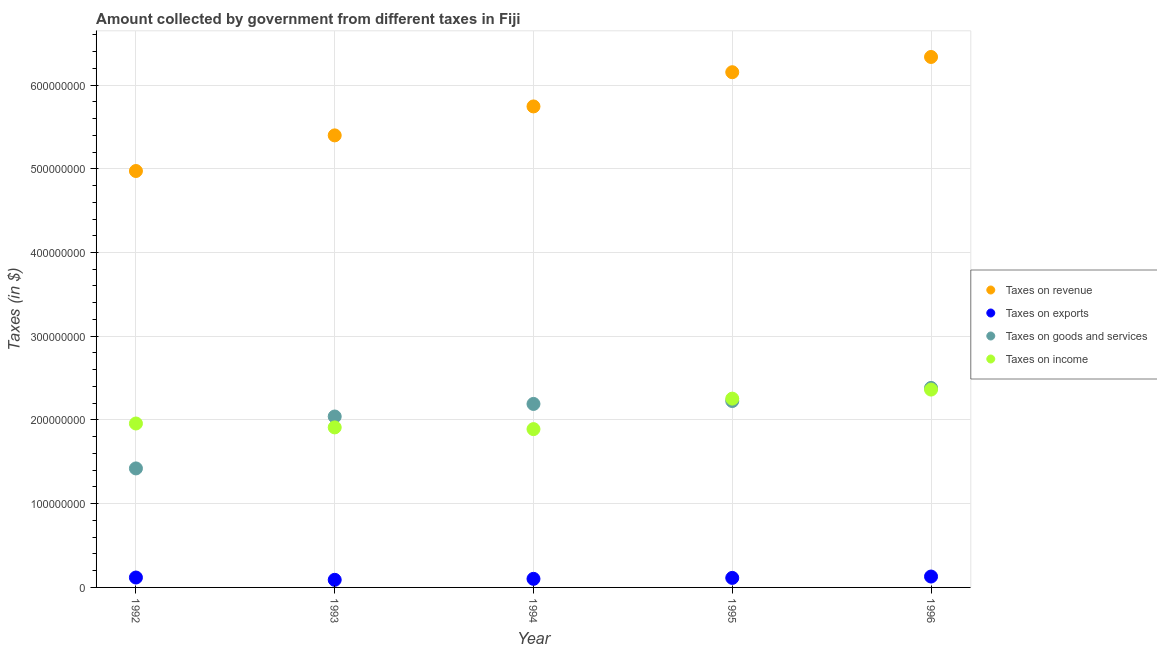How many different coloured dotlines are there?
Ensure brevity in your answer.  4. Is the number of dotlines equal to the number of legend labels?
Offer a very short reply. Yes. What is the amount collected as tax on revenue in 1996?
Your answer should be very brief. 6.34e+08. Across all years, what is the maximum amount collected as tax on income?
Offer a terse response. 2.36e+08. Across all years, what is the minimum amount collected as tax on exports?
Your answer should be very brief. 9.08e+06. In which year was the amount collected as tax on revenue maximum?
Provide a succinct answer. 1996. In which year was the amount collected as tax on exports minimum?
Offer a terse response. 1993. What is the total amount collected as tax on revenue in the graph?
Make the answer very short. 2.86e+09. What is the difference between the amount collected as tax on exports in 1993 and that in 1996?
Your response must be concise. -3.93e+06. What is the difference between the amount collected as tax on exports in 1994 and the amount collected as tax on revenue in 1992?
Your answer should be compact. -4.87e+08. What is the average amount collected as tax on goods per year?
Give a very brief answer. 2.05e+08. In the year 1994, what is the difference between the amount collected as tax on goods and amount collected as tax on income?
Your response must be concise. 3.01e+07. In how many years, is the amount collected as tax on exports greater than 220000000 $?
Your answer should be very brief. 0. What is the ratio of the amount collected as tax on goods in 1992 to that in 1995?
Provide a succinct answer. 0.64. What is the difference between the highest and the second highest amount collected as tax on exports?
Ensure brevity in your answer.  1.18e+06. What is the difference between the highest and the lowest amount collected as tax on revenue?
Keep it short and to the point. 1.36e+08. In how many years, is the amount collected as tax on income greater than the average amount collected as tax on income taken over all years?
Provide a succinct answer. 2. Is the sum of the amount collected as tax on income in 1994 and 1996 greater than the maximum amount collected as tax on revenue across all years?
Ensure brevity in your answer.  No. Is it the case that in every year, the sum of the amount collected as tax on income and amount collected as tax on exports is greater than the sum of amount collected as tax on goods and amount collected as tax on revenue?
Your answer should be very brief. No. Is it the case that in every year, the sum of the amount collected as tax on revenue and amount collected as tax on exports is greater than the amount collected as tax on goods?
Provide a succinct answer. Yes. Does the amount collected as tax on exports monotonically increase over the years?
Provide a succinct answer. No. Is the amount collected as tax on exports strictly greater than the amount collected as tax on income over the years?
Provide a succinct answer. No. What is the difference between two consecutive major ticks on the Y-axis?
Keep it short and to the point. 1.00e+08. Are the values on the major ticks of Y-axis written in scientific E-notation?
Give a very brief answer. No. Does the graph contain any zero values?
Keep it short and to the point. No. Where does the legend appear in the graph?
Make the answer very short. Center right. How are the legend labels stacked?
Give a very brief answer. Vertical. What is the title of the graph?
Your answer should be compact. Amount collected by government from different taxes in Fiji. Does "Self-employed" appear as one of the legend labels in the graph?
Give a very brief answer. No. What is the label or title of the X-axis?
Your answer should be compact. Year. What is the label or title of the Y-axis?
Ensure brevity in your answer.  Taxes (in $). What is the Taxes (in $) in Taxes on revenue in 1992?
Provide a short and direct response. 4.97e+08. What is the Taxes (in $) in Taxes on exports in 1992?
Make the answer very short. 1.18e+07. What is the Taxes (in $) in Taxes on goods and services in 1992?
Keep it short and to the point. 1.42e+08. What is the Taxes (in $) in Taxes on income in 1992?
Offer a very short reply. 1.96e+08. What is the Taxes (in $) in Taxes on revenue in 1993?
Your answer should be compact. 5.40e+08. What is the Taxes (in $) in Taxes on exports in 1993?
Keep it short and to the point. 9.08e+06. What is the Taxes (in $) of Taxes on goods and services in 1993?
Provide a succinct answer. 2.04e+08. What is the Taxes (in $) of Taxes on income in 1993?
Your response must be concise. 1.91e+08. What is the Taxes (in $) of Taxes on revenue in 1994?
Keep it short and to the point. 5.74e+08. What is the Taxes (in $) in Taxes on exports in 1994?
Your answer should be compact. 1.02e+07. What is the Taxes (in $) of Taxes on goods and services in 1994?
Offer a very short reply. 2.19e+08. What is the Taxes (in $) in Taxes on income in 1994?
Your answer should be very brief. 1.89e+08. What is the Taxes (in $) of Taxes on revenue in 1995?
Offer a very short reply. 6.15e+08. What is the Taxes (in $) in Taxes on exports in 1995?
Keep it short and to the point. 1.14e+07. What is the Taxes (in $) in Taxes on goods and services in 1995?
Keep it short and to the point. 2.23e+08. What is the Taxes (in $) of Taxes on income in 1995?
Your answer should be very brief. 2.25e+08. What is the Taxes (in $) in Taxes on revenue in 1996?
Offer a very short reply. 6.34e+08. What is the Taxes (in $) of Taxes on exports in 1996?
Your answer should be very brief. 1.30e+07. What is the Taxes (in $) in Taxes on goods and services in 1996?
Provide a short and direct response. 2.38e+08. What is the Taxes (in $) in Taxes on income in 1996?
Provide a succinct answer. 2.36e+08. Across all years, what is the maximum Taxes (in $) of Taxes on revenue?
Make the answer very short. 6.34e+08. Across all years, what is the maximum Taxes (in $) of Taxes on exports?
Offer a terse response. 1.30e+07. Across all years, what is the maximum Taxes (in $) in Taxes on goods and services?
Make the answer very short. 2.38e+08. Across all years, what is the maximum Taxes (in $) of Taxes on income?
Your response must be concise. 2.36e+08. Across all years, what is the minimum Taxes (in $) of Taxes on revenue?
Make the answer very short. 4.97e+08. Across all years, what is the minimum Taxes (in $) in Taxes on exports?
Your answer should be compact. 9.08e+06. Across all years, what is the minimum Taxes (in $) in Taxes on goods and services?
Your response must be concise. 1.42e+08. Across all years, what is the minimum Taxes (in $) in Taxes on income?
Keep it short and to the point. 1.89e+08. What is the total Taxes (in $) in Taxes on revenue in the graph?
Offer a terse response. 2.86e+09. What is the total Taxes (in $) of Taxes on exports in the graph?
Give a very brief answer. 5.55e+07. What is the total Taxes (in $) in Taxes on goods and services in the graph?
Provide a succinct answer. 1.03e+09. What is the total Taxes (in $) in Taxes on income in the graph?
Offer a terse response. 1.04e+09. What is the difference between the Taxes (in $) in Taxes on revenue in 1992 and that in 1993?
Your response must be concise. -4.26e+07. What is the difference between the Taxes (in $) of Taxes on exports in 1992 and that in 1993?
Offer a terse response. 2.75e+06. What is the difference between the Taxes (in $) in Taxes on goods and services in 1992 and that in 1993?
Your answer should be compact. -6.20e+07. What is the difference between the Taxes (in $) of Taxes on income in 1992 and that in 1993?
Ensure brevity in your answer.  4.67e+06. What is the difference between the Taxes (in $) of Taxes on revenue in 1992 and that in 1994?
Your answer should be very brief. -7.71e+07. What is the difference between the Taxes (in $) in Taxes on exports in 1992 and that in 1994?
Offer a very short reply. 1.59e+06. What is the difference between the Taxes (in $) of Taxes on goods and services in 1992 and that in 1994?
Your answer should be very brief. -7.70e+07. What is the difference between the Taxes (in $) in Taxes on income in 1992 and that in 1994?
Your response must be concise. 6.71e+06. What is the difference between the Taxes (in $) of Taxes on revenue in 1992 and that in 1995?
Your answer should be very brief. -1.18e+08. What is the difference between the Taxes (in $) of Taxes on exports in 1992 and that in 1995?
Offer a very short reply. 4.50e+05. What is the difference between the Taxes (in $) of Taxes on goods and services in 1992 and that in 1995?
Give a very brief answer. -8.05e+07. What is the difference between the Taxes (in $) of Taxes on income in 1992 and that in 1995?
Offer a very short reply. -2.97e+07. What is the difference between the Taxes (in $) in Taxes on revenue in 1992 and that in 1996?
Make the answer very short. -1.36e+08. What is the difference between the Taxes (in $) of Taxes on exports in 1992 and that in 1996?
Provide a succinct answer. -1.18e+06. What is the difference between the Taxes (in $) in Taxes on goods and services in 1992 and that in 1996?
Give a very brief answer. -9.61e+07. What is the difference between the Taxes (in $) in Taxes on income in 1992 and that in 1996?
Give a very brief answer. -4.05e+07. What is the difference between the Taxes (in $) in Taxes on revenue in 1993 and that in 1994?
Your answer should be very brief. -3.46e+07. What is the difference between the Taxes (in $) of Taxes on exports in 1993 and that in 1994?
Provide a succinct answer. -1.16e+06. What is the difference between the Taxes (in $) of Taxes on goods and services in 1993 and that in 1994?
Ensure brevity in your answer.  -1.50e+07. What is the difference between the Taxes (in $) in Taxes on income in 1993 and that in 1994?
Your answer should be compact. 2.04e+06. What is the difference between the Taxes (in $) of Taxes on revenue in 1993 and that in 1995?
Offer a terse response. -7.54e+07. What is the difference between the Taxes (in $) of Taxes on exports in 1993 and that in 1995?
Your answer should be very brief. -2.30e+06. What is the difference between the Taxes (in $) of Taxes on goods and services in 1993 and that in 1995?
Provide a succinct answer. -1.85e+07. What is the difference between the Taxes (in $) in Taxes on income in 1993 and that in 1995?
Give a very brief answer. -3.44e+07. What is the difference between the Taxes (in $) in Taxes on revenue in 1993 and that in 1996?
Give a very brief answer. -9.36e+07. What is the difference between the Taxes (in $) in Taxes on exports in 1993 and that in 1996?
Your answer should be very brief. -3.93e+06. What is the difference between the Taxes (in $) of Taxes on goods and services in 1993 and that in 1996?
Offer a very short reply. -3.41e+07. What is the difference between the Taxes (in $) in Taxes on income in 1993 and that in 1996?
Your response must be concise. -4.52e+07. What is the difference between the Taxes (in $) of Taxes on revenue in 1994 and that in 1995?
Keep it short and to the point. -4.09e+07. What is the difference between the Taxes (in $) of Taxes on exports in 1994 and that in 1995?
Your answer should be very brief. -1.14e+06. What is the difference between the Taxes (in $) of Taxes on goods and services in 1994 and that in 1995?
Offer a very short reply. -3.46e+06. What is the difference between the Taxes (in $) of Taxes on income in 1994 and that in 1995?
Give a very brief answer. -3.64e+07. What is the difference between the Taxes (in $) of Taxes on revenue in 1994 and that in 1996?
Your answer should be very brief. -5.91e+07. What is the difference between the Taxes (in $) in Taxes on exports in 1994 and that in 1996?
Provide a succinct answer. -2.77e+06. What is the difference between the Taxes (in $) of Taxes on goods and services in 1994 and that in 1996?
Provide a short and direct response. -1.91e+07. What is the difference between the Taxes (in $) of Taxes on income in 1994 and that in 1996?
Offer a very short reply. -4.72e+07. What is the difference between the Taxes (in $) of Taxes on revenue in 1995 and that in 1996?
Provide a succinct answer. -1.82e+07. What is the difference between the Taxes (in $) in Taxes on exports in 1995 and that in 1996?
Provide a short and direct response. -1.63e+06. What is the difference between the Taxes (in $) in Taxes on goods and services in 1995 and that in 1996?
Your answer should be compact. -1.56e+07. What is the difference between the Taxes (in $) of Taxes on income in 1995 and that in 1996?
Ensure brevity in your answer.  -1.08e+07. What is the difference between the Taxes (in $) in Taxes on revenue in 1992 and the Taxes (in $) in Taxes on exports in 1993?
Offer a terse response. 4.88e+08. What is the difference between the Taxes (in $) of Taxes on revenue in 1992 and the Taxes (in $) of Taxes on goods and services in 1993?
Provide a short and direct response. 2.93e+08. What is the difference between the Taxes (in $) in Taxes on revenue in 1992 and the Taxes (in $) in Taxes on income in 1993?
Offer a very short reply. 3.06e+08. What is the difference between the Taxes (in $) of Taxes on exports in 1992 and the Taxes (in $) of Taxes on goods and services in 1993?
Your answer should be compact. -1.92e+08. What is the difference between the Taxes (in $) in Taxes on exports in 1992 and the Taxes (in $) in Taxes on income in 1993?
Your answer should be very brief. -1.79e+08. What is the difference between the Taxes (in $) of Taxes on goods and services in 1992 and the Taxes (in $) of Taxes on income in 1993?
Offer a terse response. -4.90e+07. What is the difference between the Taxes (in $) in Taxes on revenue in 1992 and the Taxes (in $) in Taxes on exports in 1994?
Offer a terse response. 4.87e+08. What is the difference between the Taxes (in $) in Taxes on revenue in 1992 and the Taxes (in $) in Taxes on goods and services in 1994?
Offer a very short reply. 2.78e+08. What is the difference between the Taxes (in $) in Taxes on revenue in 1992 and the Taxes (in $) in Taxes on income in 1994?
Your answer should be compact. 3.08e+08. What is the difference between the Taxes (in $) in Taxes on exports in 1992 and the Taxes (in $) in Taxes on goods and services in 1994?
Give a very brief answer. -2.07e+08. What is the difference between the Taxes (in $) of Taxes on exports in 1992 and the Taxes (in $) of Taxes on income in 1994?
Ensure brevity in your answer.  -1.77e+08. What is the difference between the Taxes (in $) in Taxes on goods and services in 1992 and the Taxes (in $) in Taxes on income in 1994?
Provide a short and direct response. -4.69e+07. What is the difference between the Taxes (in $) of Taxes on revenue in 1992 and the Taxes (in $) of Taxes on exports in 1995?
Your answer should be compact. 4.86e+08. What is the difference between the Taxes (in $) of Taxes on revenue in 1992 and the Taxes (in $) of Taxes on goods and services in 1995?
Give a very brief answer. 2.75e+08. What is the difference between the Taxes (in $) in Taxes on revenue in 1992 and the Taxes (in $) in Taxes on income in 1995?
Offer a terse response. 2.72e+08. What is the difference between the Taxes (in $) in Taxes on exports in 1992 and the Taxes (in $) in Taxes on goods and services in 1995?
Make the answer very short. -2.11e+08. What is the difference between the Taxes (in $) in Taxes on exports in 1992 and the Taxes (in $) in Taxes on income in 1995?
Offer a terse response. -2.14e+08. What is the difference between the Taxes (in $) in Taxes on goods and services in 1992 and the Taxes (in $) in Taxes on income in 1995?
Offer a terse response. -8.33e+07. What is the difference between the Taxes (in $) of Taxes on revenue in 1992 and the Taxes (in $) of Taxes on exports in 1996?
Give a very brief answer. 4.84e+08. What is the difference between the Taxes (in $) of Taxes on revenue in 1992 and the Taxes (in $) of Taxes on goods and services in 1996?
Provide a short and direct response. 2.59e+08. What is the difference between the Taxes (in $) of Taxes on revenue in 1992 and the Taxes (in $) of Taxes on income in 1996?
Ensure brevity in your answer.  2.61e+08. What is the difference between the Taxes (in $) in Taxes on exports in 1992 and the Taxes (in $) in Taxes on goods and services in 1996?
Provide a short and direct response. -2.26e+08. What is the difference between the Taxes (in $) of Taxes on exports in 1992 and the Taxes (in $) of Taxes on income in 1996?
Give a very brief answer. -2.24e+08. What is the difference between the Taxes (in $) in Taxes on goods and services in 1992 and the Taxes (in $) in Taxes on income in 1996?
Offer a very short reply. -9.42e+07. What is the difference between the Taxes (in $) in Taxes on revenue in 1993 and the Taxes (in $) in Taxes on exports in 1994?
Your answer should be very brief. 5.30e+08. What is the difference between the Taxes (in $) of Taxes on revenue in 1993 and the Taxes (in $) of Taxes on goods and services in 1994?
Give a very brief answer. 3.21e+08. What is the difference between the Taxes (in $) of Taxes on revenue in 1993 and the Taxes (in $) of Taxes on income in 1994?
Your answer should be compact. 3.51e+08. What is the difference between the Taxes (in $) of Taxes on exports in 1993 and the Taxes (in $) of Taxes on goods and services in 1994?
Ensure brevity in your answer.  -2.10e+08. What is the difference between the Taxes (in $) of Taxes on exports in 1993 and the Taxes (in $) of Taxes on income in 1994?
Your answer should be very brief. -1.80e+08. What is the difference between the Taxes (in $) of Taxes on goods and services in 1993 and the Taxes (in $) of Taxes on income in 1994?
Give a very brief answer. 1.51e+07. What is the difference between the Taxes (in $) of Taxes on revenue in 1993 and the Taxes (in $) of Taxes on exports in 1995?
Your answer should be very brief. 5.28e+08. What is the difference between the Taxes (in $) of Taxes on revenue in 1993 and the Taxes (in $) of Taxes on goods and services in 1995?
Your response must be concise. 3.17e+08. What is the difference between the Taxes (in $) in Taxes on revenue in 1993 and the Taxes (in $) in Taxes on income in 1995?
Offer a very short reply. 3.14e+08. What is the difference between the Taxes (in $) in Taxes on exports in 1993 and the Taxes (in $) in Taxes on goods and services in 1995?
Make the answer very short. -2.14e+08. What is the difference between the Taxes (in $) in Taxes on exports in 1993 and the Taxes (in $) in Taxes on income in 1995?
Your answer should be very brief. -2.16e+08. What is the difference between the Taxes (in $) of Taxes on goods and services in 1993 and the Taxes (in $) of Taxes on income in 1995?
Make the answer very short. -2.13e+07. What is the difference between the Taxes (in $) of Taxes on revenue in 1993 and the Taxes (in $) of Taxes on exports in 1996?
Keep it short and to the point. 5.27e+08. What is the difference between the Taxes (in $) in Taxes on revenue in 1993 and the Taxes (in $) in Taxes on goods and services in 1996?
Ensure brevity in your answer.  3.02e+08. What is the difference between the Taxes (in $) of Taxes on revenue in 1993 and the Taxes (in $) of Taxes on income in 1996?
Offer a very short reply. 3.04e+08. What is the difference between the Taxes (in $) of Taxes on exports in 1993 and the Taxes (in $) of Taxes on goods and services in 1996?
Keep it short and to the point. -2.29e+08. What is the difference between the Taxes (in $) of Taxes on exports in 1993 and the Taxes (in $) of Taxes on income in 1996?
Offer a very short reply. -2.27e+08. What is the difference between the Taxes (in $) in Taxes on goods and services in 1993 and the Taxes (in $) in Taxes on income in 1996?
Ensure brevity in your answer.  -3.22e+07. What is the difference between the Taxes (in $) in Taxes on revenue in 1994 and the Taxes (in $) in Taxes on exports in 1995?
Ensure brevity in your answer.  5.63e+08. What is the difference between the Taxes (in $) of Taxes on revenue in 1994 and the Taxes (in $) of Taxes on goods and services in 1995?
Make the answer very short. 3.52e+08. What is the difference between the Taxes (in $) in Taxes on revenue in 1994 and the Taxes (in $) in Taxes on income in 1995?
Make the answer very short. 3.49e+08. What is the difference between the Taxes (in $) of Taxes on exports in 1994 and the Taxes (in $) of Taxes on goods and services in 1995?
Provide a succinct answer. -2.12e+08. What is the difference between the Taxes (in $) of Taxes on exports in 1994 and the Taxes (in $) of Taxes on income in 1995?
Provide a short and direct response. -2.15e+08. What is the difference between the Taxes (in $) of Taxes on goods and services in 1994 and the Taxes (in $) of Taxes on income in 1995?
Give a very brief answer. -6.33e+06. What is the difference between the Taxes (in $) of Taxes on revenue in 1994 and the Taxes (in $) of Taxes on exports in 1996?
Make the answer very short. 5.61e+08. What is the difference between the Taxes (in $) in Taxes on revenue in 1994 and the Taxes (in $) in Taxes on goods and services in 1996?
Your response must be concise. 3.36e+08. What is the difference between the Taxes (in $) in Taxes on revenue in 1994 and the Taxes (in $) in Taxes on income in 1996?
Offer a terse response. 3.38e+08. What is the difference between the Taxes (in $) in Taxes on exports in 1994 and the Taxes (in $) in Taxes on goods and services in 1996?
Give a very brief answer. -2.28e+08. What is the difference between the Taxes (in $) in Taxes on exports in 1994 and the Taxes (in $) in Taxes on income in 1996?
Your answer should be compact. -2.26e+08. What is the difference between the Taxes (in $) of Taxes on goods and services in 1994 and the Taxes (in $) of Taxes on income in 1996?
Offer a very short reply. -1.72e+07. What is the difference between the Taxes (in $) in Taxes on revenue in 1995 and the Taxes (in $) in Taxes on exports in 1996?
Provide a short and direct response. 6.02e+08. What is the difference between the Taxes (in $) in Taxes on revenue in 1995 and the Taxes (in $) in Taxes on goods and services in 1996?
Make the answer very short. 3.77e+08. What is the difference between the Taxes (in $) of Taxes on revenue in 1995 and the Taxes (in $) of Taxes on income in 1996?
Offer a terse response. 3.79e+08. What is the difference between the Taxes (in $) of Taxes on exports in 1995 and the Taxes (in $) of Taxes on goods and services in 1996?
Provide a succinct answer. -2.27e+08. What is the difference between the Taxes (in $) of Taxes on exports in 1995 and the Taxes (in $) of Taxes on income in 1996?
Your response must be concise. -2.25e+08. What is the difference between the Taxes (in $) of Taxes on goods and services in 1995 and the Taxes (in $) of Taxes on income in 1996?
Your answer should be compact. -1.37e+07. What is the average Taxes (in $) in Taxes on revenue per year?
Your response must be concise. 5.72e+08. What is the average Taxes (in $) of Taxes on exports per year?
Offer a terse response. 1.11e+07. What is the average Taxes (in $) of Taxes on goods and services per year?
Offer a very short reply. 2.05e+08. What is the average Taxes (in $) of Taxes on income per year?
Provide a succinct answer. 2.08e+08. In the year 1992, what is the difference between the Taxes (in $) of Taxes on revenue and Taxes (in $) of Taxes on exports?
Offer a terse response. 4.85e+08. In the year 1992, what is the difference between the Taxes (in $) in Taxes on revenue and Taxes (in $) in Taxes on goods and services?
Keep it short and to the point. 3.55e+08. In the year 1992, what is the difference between the Taxes (in $) of Taxes on revenue and Taxes (in $) of Taxes on income?
Provide a short and direct response. 3.02e+08. In the year 1992, what is the difference between the Taxes (in $) of Taxes on exports and Taxes (in $) of Taxes on goods and services?
Provide a short and direct response. -1.30e+08. In the year 1992, what is the difference between the Taxes (in $) in Taxes on exports and Taxes (in $) in Taxes on income?
Keep it short and to the point. -1.84e+08. In the year 1992, what is the difference between the Taxes (in $) in Taxes on goods and services and Taxes (in $) in Taxes on income?
Your answer should be compact. -5.36e+07. In the year 1993, what is the difference between the Taxes (in $) of Taxes on revenue and Taxes (in $) of Taxes on exports?
Provide a succinct answer. 5.31e+08. In the year 1993, what is the difference between the Taxes (in $) of Taxes on revenue and Taxes (in $) of Taxes on goods and services?
Provide a succinct answer. 3.36e+08. In the year 1993, what is the difference between the Taxes (in $) in Taxes on revenue and Taxes (in $) in Taxes on income?
Make the answer very short. 3.49e+08. In the year 1993, what is the difference between the Taxes (in $) of Taxes on exports and Taxes (in $) of Taxes on goods and services?
Ensure brevity in your answer.  -1.95e+08. In the year 1993, what is the difference between the Taxes (in $) of Taxes on exports and Taxes (in $) of Taxes on income?
Provide a short and direct response. -1.82e+08. In the year 1993, what is the difference between the Taxes (in $) of Taxes on goods and services and Taxes (in $) of Taxes on income?
Ensure brevity in your answer.  1.30e+07. In the year 1994, what is the difference between the Taxes (in $) in Taxes on revenue and Taxes (in $) in Taxes on exports?
Offer a very short reply. 5.64e+08. In the year 1994, what is the difference between the Taxes (in $) of Taxes on revenue and Taxes (in $) of Taxes on goods and services?
Your response must be concise. 3.55e+08. In the year 1994, what is the difference between the Taxes (in $) in Taxes on revenue and Taxes (in $) in Taxes on income?
Your response must be concise. 3.85e+08. In the year 1994, what is the difference between the Taxes (in $) of Taxes on exports and Taxes (in $) of Taxes on goods and services?
Your answer should be very brief. -2.09e+08. In the year 1994, what is the difference between the Taxes (in $) in Taxes on exports and Taxes (in $) in Taxes on income?
Make the answer very short. -1.79e+08. In the year 1994, what is the difference between the Taxes (in $) in Taxes on goods and services and Taxes (in $) in Taxes on income?
Your response must be concise. 3.01e+07. In the year 1995, what is the difference between the Taxes (in $) in Taxes on revenue and Taxes (in $) in Taxes on exports?
Make the answer very short. 6.04e+08. In the year 1995, what is the difference between the Taxes (in $) of Taxes on revenue and Taxes (in $) of Taxes on goods and services?
Your answer should be compact. 3.93e+08. In the year 1995, what is the difference between the Taxes (in $) in Taxes on revenue and Taxes (in $) in Taxes on income?
Offer a very short reply. 3.90e+08. In the year 1995, what is the difference between the Taxes (in $) in Taxes on exports and Taxes (in $) in Taxes on goods and services?
Give a very brief answer. -2.11e+08. In the year 1995, what is the difference between the Taxes (in $) in Taxes on exports and Taxes (in $) in Taxes on income?
Your answer should be very brief. -2.14e+08. In the year 1995, what is the difference between the Taxes (in $) of Taxes on goods and services and Taxes (in $) of Taxes on income?
Make the answer very short. -2.87e+06. In the year 1996, what is the difference between the Taxes (in $) in Taxes on revenue and Taxes (in $) in Taxes on exports?
Offer a terse response. 6.21e+08. In the year 1996, what is the difference between the Taxes (in $) of Taxes on revenue and Taxes (in $) of Taxes on goods and services?
Provide a short and direct response. 3.95e+08. In the year 1996, what is the difference between the Taxes (in $) of Taxes on revenue and Taxes (in $) of Taxes on income?
Ensure brevity in your answer.  3.97e+08. In the year 1996, what is the difference between the Taxes (in $) in Taxes on exports and Taxes (in $) in Taxes on goods and services?
Provide a succinct answer. -2.25e+08. In the year 1996, what is the difference between the Taxes (in $) of Taxes on exports and Taxes (in $) of Taxes on income?
Make the answer very short. -2.23e+08. In the year 1996, what is the difference between the Taxes (in $) of Taxes on goods and services and Taxes (in $) of Taxes on income?
Keep it short and to the point. 1.96e+06. What is the ratio of the Taxes (in $) of Taxes on revenue in 1992 to that in 1993?
Offer a terse response. 0.92. What is the ratio of the Taxes (in $) in Taxes on exports in 1992 to that in 1993?
Ensure brevity in your answer.  1.3. What is the ratio of the Taxes (in $) in Taxes on goods and services in 1992 to that in 1993?
Your answer should be very brief. 0.7. What is the ratio of the Taxes (in $) in Taxes on income in 1992 to that in 1993?
Give a very brief answer. 1.02. What is the ratio of the Taxes (in $) in Taxes on revenue in 1992 to that in 1994?
Offer a terse response. 0.87. What is the ratio of the Taxes (in $) of Taxes on exports in 1992 to that in 1994?
Offer a terse response. 1.16. What is the ratio of the Taxes (in $) in Taxes on goods and services in 1992 to that in 1994?
Keep it short and to the point. 0.65. What is the ratio of the Taxes (in $) in Taxes on income in 1992 to that in 1994?
Keep it short and to the point. 1.04. What is the ratio of the Taxes (in $) in Taxes on revenue in 1992 to that in 1995?
Provide a succinct answer. 0.81. What is the ratio of the Taxes (in $) in Taxes on exports in 1992 to that in 1995?
Provide a succinct answer. 1.04. What is the ratio of the Taxes (in $) of Taxes on goods and services in 1992 to that in 1995?
Give a very brief answer. 0.64. What is the ratio of the Taxes (in $) of Taxes on income in 1992 to that in 1995?
Provide a succinct answer. 0.87. What is the ratio of the Taxes (in $) of Taxes on revenue in 1992 to that in 1996?
Give a very brief answer. 0.79. What is the ratio of the Taxes (in $) of Taxes on exports in 1992 to that in 1996?
Give a very brief answer. 0.91. What is the ratio of the Taxes (in $) in Taxes on goods and services in 1992 to that in 1996?
Offer a very short reply. 0.6. What is the ratio of the Taxes (in $) of Taxes on income in 1992 to that in 1996?
Your response must be concise. 0.83. What is the ratio of the Taxes (in $) in Taxes on revenue in 1993 to that in 1994?
Provide a short and direct response. 0.94. What is the ratio of the Taxes (in $) in Taxes on exports in 1993 to that in 1994?
Give a very brief answer. 0.89. What is the ratio of the Taxes (in $) of Taxes on goods and services in 1993 to that in 1994?
Keep it short and to the point. 0.93. What is the ratio of the Taxes (in $) of Taxes on income in 1993 to that in 1994?
Ensure brevity in your answer.  1.01. What is the ratio of the Taxes (in $) of Taxes on revenue in 1993 to that in 1995?
Give a very brief answer. 0.88. What is the ratio of the Taxes (in $) in Taxes on exports in 1993 to that in 1995?
Make the answer very short. 0.8. What is the ratio of the Taxes (in $) in Taxes on goods and services in 1993 to that in 1995?
Your answer should be very brief. 0.92. What is the ratio of the Taxes (in $) of Taxes on income in 1993 to that in 1995?
Provide a succinct answer. 0.85. What is the ratio of the Taxes (in $) in Taxes on revenue in 1993 to that in 1996?
Offer a very short reply. 0.85. What is the ratio of the Taxes (in $) of Taxes on exports in 1993 to that in 1996?
Provide a short and direct response. 0.7. What is the ratio of the Taxes (in $) in Taxes on goods and services in 1993 to that in 1996?
Your answer should be very brief. 0.86. What is the ratio of the Taxes (in $) in Taxes on income in 1993 to that in 1996?
Provide a succinct answer. 0.81. What is the ratio of the Taxes (in $) of Taxes on revenue in 1994 to that in 1995?
Keep it short and to the point. 0.93. What is the ratio of the Taxes (in $) of Taxes on exports in 1994 to that in 1995?
Keep it short and to the point. 0.9. What is the ratio of the Taxes (in $) in Taxes on goods and services in 1994 to that in 1995?
Provide a short and direct response. 0.98. What is the ratio of the Taxes (in $) of Taxes on income in 1994 to that in 1995?
Your answer should be compact. 0.84. What is the ratio of the Taxes (in $) in Taxes on revenue in 1994 to that in 1996?
Make the answer very short. 0.91. What is the ratio of the Taxes (in $) of Taxes on exports in 1994 to that in 1996?
Ensure brevity in your answer.  0.79. What is the ratio of the Taxes (in $) in Taxes on goods and services in 1994 to that in 1996?
Make the answer very short. 0.92. What is the ratio of the Taxes (in $) of Taxes on income in 1994 to that in 1996?
Make the answer very short. 0.8. What is the ratio of the Taxes (in $) of Taxes on revenue in 1995 to that in 1996?
Your answer should be compact. 0.97. What is the ratio of the Taxes (in $) in Taxes on exports in 1995 to that in 1996?
Your answer should be very brief. 0.87. What is the ratio of the Taxes (in $) in Taxes on goods and services in 1995 to that in 1996?
Offer a very short reply. 0.93. What is the ratio of the Taxes (in $) of Taxes on income in 1995 to that in 1996?
Your answer should be compact. 0.95. What is the difference between the highest and the second highest Taxes (in $) of Taxes on revenue?
Provide a succinct answer. 1.82e+07. What is the difference between the highest and the second highest Taxes (in $) in Taxes on exports?
Provide a succinct answer. 1.18e+06. What is the difference between the highest and the second highest Taxes (in $) in Taxes on goods and services?
Offer a terse response. 1.56e+07. What is the difference between the highest and the second highest Taxes (in $) in Taxes on income?
Give a very brief answer. 1.08e+07. What is the difference between the highest and the lowest Taxes (in $) in Taxes on revenue?
Your response must be concise. 1.36e+08. What is the difference between the highest and the lowest Taxes (in $) in Taxes on exports?
Make the answer very short. 3.93e+06. What is the difference between the highest and the lowest Taxes (in $) in Taxes on goods and services?
Provide a succinct answer. 9.61e+07. What is the difference between the highest and the lowest Taxes (in $) in Taxes on income?
Ensure brevity in your answer.  4.72e+07. 